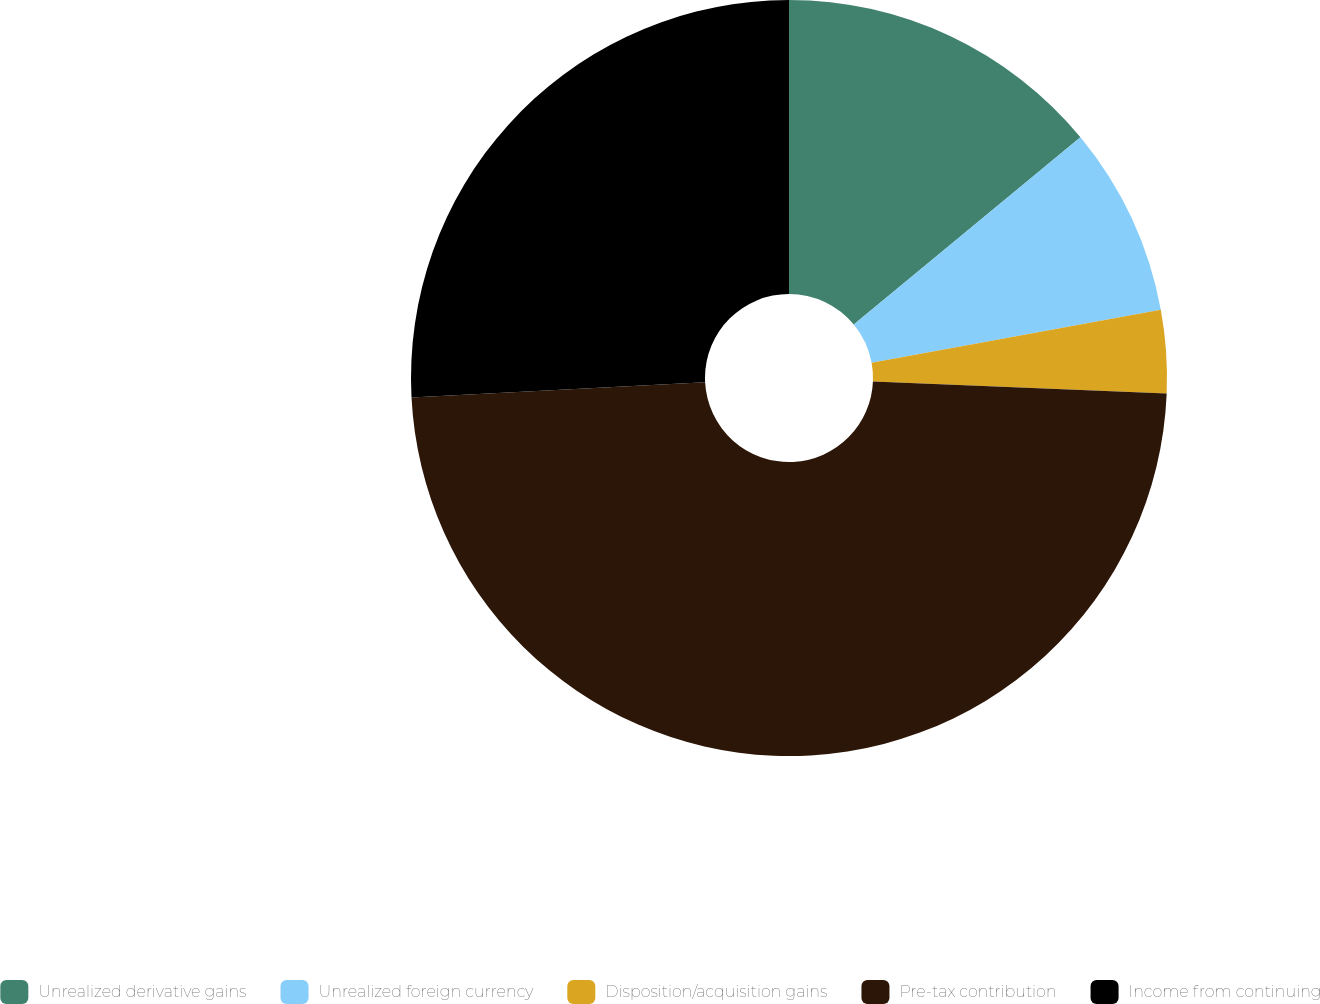<chart> <loc_0><loc_0><loc_500><loc_500><pie_chart><fcel>Unrealized derivative gains<fcel>Unrealized foreign currency<fcel>Disposition/acquisition gains<fcel>Pre-tax contribution<fcel>Income from continuing<nl><fcel>14.01%<fcel>8.1%<fcel>3.54%<fcel>48.52%<fcel>25.82%<nl></chart> 